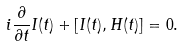<formula> <loc_0><loc_0><loc_500><loc_500>i \frac { \partial } { \partial t } I ( t ) + [ I ( t ) , H ( t ) ] = 0 .</formula> 